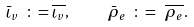Convert formula to latex. <formula><loc_0><loc_0><loc_500><loc_500>\bar { \iota } _ { v } \ \colon = \overline { \iota _ { v } } , \quad \ \bar { \rho } _ { e } \ \colon = \ \overline { \rho _ { e } } .</formula> 